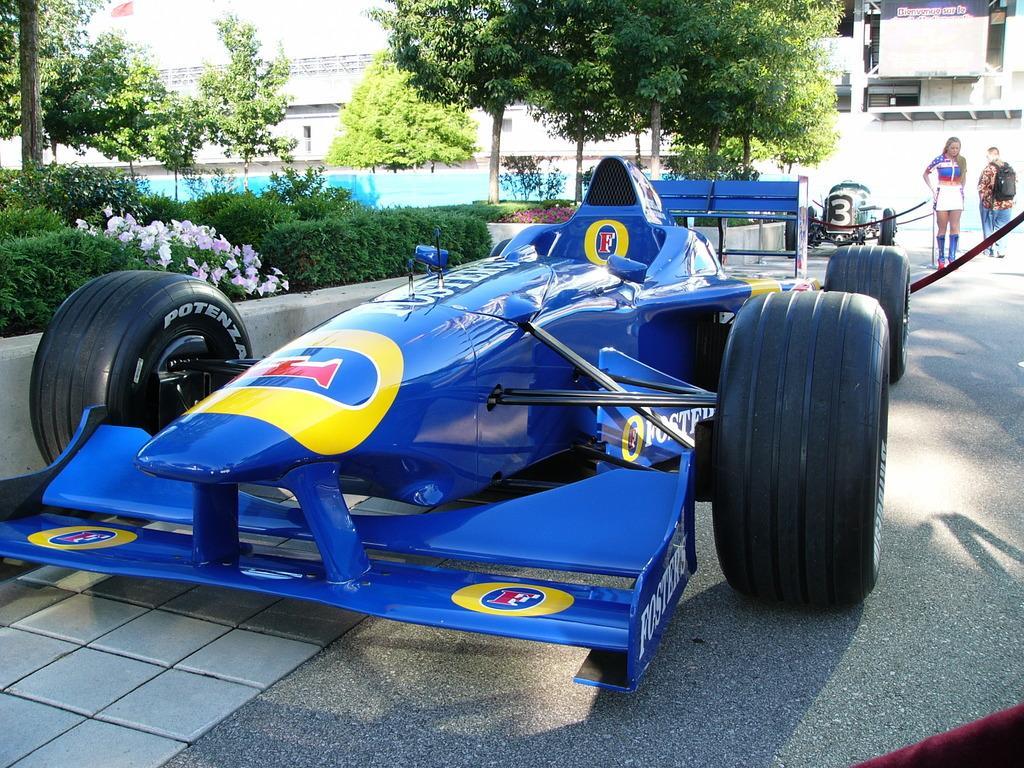Could you give a brief overview of what you see in this image? In this image there is a vehicle on the road, behind the vehicle there are two people walking on the road, on the other side of the image there are trees, plants and flowers. In the background there are buildings. 